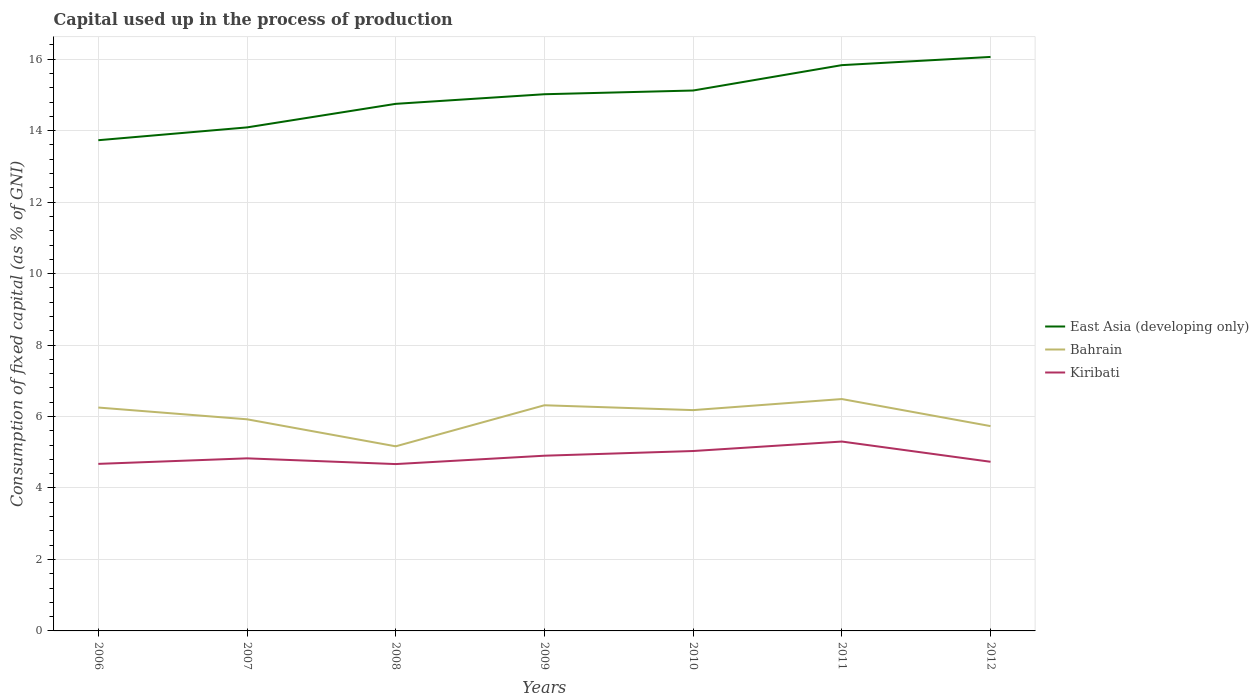How many different coloured lines are there?
Make the answer very short. 3. Is the number of lines equal to the number of legend labels?
Offer a very short reply. Yes. Across all years, what is the maximum capital used up in the process of production in Kiribati?
Keep it short and to the point. 4.67. In which year was the capital used up in the process of production in Bahrain maximum?
Provide a short and direct response. 2008. What is the total capital used up in the process of production in Bahrain in the graph?
Provide a succinct answer. -1.32. What is the difference between the highest and the second highest capital used up in the process of production in East Asia (developing only)?
Your answer should be compact. 2.33. How many years are there in the graph?
Ensure brevity in your answer.  7. What is the difference between two consecutive major ticks on the Y-axis?
Your answer should be very brief. 2. Does the graph contain any zero values?
Offer a terse response. No. Does the graph contain grids?
Make the answer very short. Yes. How many legend labels are there?
Your answer should be very brief. 3. How are the legend labels stacked?
Provide a short and direct response. Vertical. What is the title of the graph?
Ensure brevity in your answer.  Capital used up in the process of production. Does "Jordan" appear as one of the legend labels in the graph?
Keep it short and to the point. No. What is the label or title of the Y-axis?
Provide a short and direct response. Consumption of fixed capital (as % of GNI). What is the Consumption of fixed capital (as % of GNI) in East Asia (developing only) in 2006?
Offer a very short reply. 13.73. What is the Consumption of fixed capital (as % of GNI) in Bahrain in 2006?
Keep it short and to the point. 6.25. What is the Consumption of fixed capital (as % of GNI) in Kiribati in 2006?
Your answer should be very brief. 4.68. What is the Consumption of fixed capital (as % of GNI) in East Asia (developing only) in 2007?
Your answer should be very brief. 14.09. What is the Consumption of fixed capital (as % of GNI) in Bahrain in 2007?
Your answer should be compact. 5.92. What is the Consumption of fixed capital (as % of GNI) of Kiribati in 2007?
Provide a succinct answer. 4.83. What is the Consumption of fixed capital (as % of GNI) of East Asia (developing only) in 2008?
Ensure brevity in your answer.  14.75. What is the Consumption of fixed capital (as % of GNI) of Bahrain in 2008?
Offer a terse response. 5.17. What is the Consumption of fixed capital (as % of GNI) of Kiribati in 2008?
Offer a terse response. 4.67. What is the Consumption of fixed capital (as % of GNI) in East Asia (developing only) in 2009?
Provide a short and direct response. 15.02. What is the Consumption of fixed capital (as % of GNI) of Bahrain in 2009?
Ensure brevity in your answer.  6.32. What is the Consumption of fixed capital (as % of GNI) of Kiribati in 2009?
Provide a short and direct response. 4.9. What is the Consumption of fixed capital (as % of GNI) in East Asia (developing only) in 2010?
Make the answer very short. 15.12. What is the Consumption of fixed capital (as % of GNI) of Bahrain in 2010?
Give a very brief answer. 6.18. What is the Consumption of fixed capital (as % of GNI) of Kiribati in 2010?
Keep it short and to the point. 5.03. What is the Consumption of fixed capital (as % of GNI) in East Asia (developing only) in 2011?
Your response must be concise. 15.83. What is the Consumption of fixed capital (as % of GNI) of Bahrain in 2011?
Offer a terse response. 6.49. What is the Consumption of fixed capital (as % of GNI) of Kiribati in 2011?
Keep it short and to the point. 5.3. What is the Consumption of fixed capital (as % of GNI) of East Asia (developing only) in 2012?
Your answer should be very brief. 16.06. What is the Consumption of fixed capital (as % of GNI) in Bahrain in 2012?
Keep it short and to the point. 5.73. What is the Consumption of fixed capital (as % of GNI) in Kiribati in 2012?
Offer a very short reply. 4.73. Across all years, what is the maximum Consumption of fixed capital (as % of GNI) in East Asia (developing only)?
Your answer should be very brief. 16.06. Across all years, what is the maximum Consumption of fixed capital (as % of GNI) in Bahrain?
Your answer should be very brief. 6.49. Across all years, what is the maximum Consumption of fixed capital (as % of GNI) in Kiribati?
Offer a very short reply. 5.3. Across all years, what is the minimum Consumption of fixed capital (as % of GNI) in East Asia (developing only)?
Your answer should be compact. 13.73. Across all years, what is the minimum Consumption of fixed capital (as % of GNI) in Bahrain?
Your answer should be compact. 5.17. Across all years, what is the minimum Consumption of fixed capital (as % of GNI) in Kiribati?
Your answer should be compact. 4.67. What is the total Consumption of fixed capital (as % of GNI) in East Asia (developing only) in the graph?
Your response must be concise. 104.61. What is the total Consumption of fixed capital (as % of GNI) in Bahrain in the graph?
Make the answer very short. 42.06. What is the total Consumption of fixed capital (as % of GNI) in Kiribati in the graph?
Offer a very short reply. 34.15. What is the difference between the Consumption of fixed capital (as % of GNI) of East Asia (developing only) in 2006 and that in 2007?
Provide a succinct answer. -0.36. What is the difference between the Consumption of fixed capital (as % of GNI) of Bahrain in 2006 and that in 2007?
Your response must be concise. 0.33. What is the difference between the Consumption of fixed capital (as % of GNI) of Kiribati in 2006 and that in 2007?
Offer a very short reply. -0.15. What is the difference between the Consumption of fixed capital (as % of GNI) of East Asia (developing only) in 2006 and that in 2008?
Your answer should be very brief. -1.02. What is the difference between the Consumption of fixed capital (as % of GNI) of Bahrain in 2006 and that in 2008?
Ensure brevity in your answer.  1.09. What is the difference between the Consumption of fixed capital (as % of GNI) of Kiribati in 2006 and that in 2008?
Offer a very short reply. 0.01. What is the difference between the Consumption of fixed capital (as % of GNI) of East Asia (developing only) in 2006 and that in 2009?
Keep it short and to the point. -1.29. What is the difference between the Consumption of fixed capital (as % of GNI) in Bahrain in 2006 and that in 2009?
Make the answer very short. -0.06. What is the difference between the Consumption of fixed capital (as % of GNI) of Kiribati in 2006 and that in 2009?
Keep it short and to the point. -0.23. What is the difference between the Consumption of fixed capital (as % of GNI) in East Asia (developing only) in 2006 and that in 2010?
Make the answer very short. -1.39. What is the difference between the Consumption of fixed capital (as % of GNI) of Bahrain in 2006 and that in 2010?
Give a very brief answer. 0.07. What is the difference between the Consumption of fixed capital (as % of GNI) of Kiribati in 2006 and that in 2010?
Give a very brief answer. -0.36. What is the difference between the Consumption of fixed capital (as % of GNI) in East Asia (developing only) in 2006 and that in 2011?
Provide a succinct answer. -2.1. What is the difference between the Consumption of fixed capital (as % of GNI) of Bahrain in 2006 and that in 2011?
Offer a terse response. -0.24. What is the difference between the Consumption of fixed capital (as % of GNI) of Kiribati in 2006 and that in 2011?
Make the answer very short. -0.62. What is the difference between the Consumption of fixed capital (as % of GNI) of East Asia (developing only) in 2006 and that in 2012?
Keep it short and to the point. -2.33. What is the difference between the Consumption of fixed capital (as % of GNI) of Bahrain in 2006 and that in 2012?
Offer a very short reply. 0.52. What is the difference between the Consumption of fixed capital (as % of GNI) of Kiribati in 2006 and that in 2012?
Provide a succinct answer. -0.06. What is the difference between the Consumption of fixed capital (as % of GNI) of East Asia (developing only) in 2007 and that in 2008?
Offer a very short reply. -0.66. What is the difference between the Consumption of fixed capital (as % of GNI) in Bahrain in 2007 and that in 2008?
Your answer should be very brief. 0.76. What is the difference between the Consumption of fixed capital (as % of GNI) of Kiribati in 2007 and that in 2008?
Give a very brief answer. 0.16. What is the difference between the Consumption of fixed capital (as % of GNI) in East Asia (developing only) in 2007 and that in 2009?
Give a very brief answer. -0.93. What is the difference between the Consumption of fixed capital (as % of GNI) in Bahrain in 2007 and that in 2009?
Provide a short and direct response. -0.39. What is the difference between the Consumption of fixed capital (as % of GNI) in Kiribati in 2007 and that in 2009?
Ensure brevity in your answer.  -0.07. What is the difference between the Consumption of fixed capital (as % of GNI) in East Asia (developing only) in 2007 and that in 2010?
Provide a succinct answer. -1.03. What is the difference between the Consumption of fixed capital (as % of GNI) of Bahrain in 2007 and that in 2010?
Provide a short and direct response. -0.26. What is the difference between the Consumption of fixed capital (as % of GNI) of Kiribati in 2007 and that in 2010?
Offer a very short reply. -0.21. What is the difference between the Consumption of fixed capital (as % of GNI) in East Asia (developing only) in 2007 and that in 2011?
Your answer should be compact. -1.74. What is the difference between the Consumption of fixed capital (as % of GNI) in Bahrain in 2007 and that in 2011?
Offer a very short reply. -0.57. What is the difference between the Consumption of fixed capital (as % of GNI) in Kiribati in 2007 and that in 2011?
Offer a terse response. -0.47. What is the difference between the Consumption of fixed capital (as % of GNI) of East Asia (developing only) in 2007 and that in 2012?
Offer a terse response. -1.97. What is the difference between the Consumption of fixed capital (as % of GNI) of Bahrain in 2007 and that in 2012?
Give a very brief answer. 0.19. What is the difference between the Consumption of fixed capital (as % of GNI) in Kiribati in 2007 and that in 2012?
Ensure brevity in your answer.  0.1. What is the difference between the Consumption of fixed capital (as % of GNI) of East Asia (developing only) in 2008 and that in 2009?
Your response must be concise. -0.27. What is the difference between the Consumption of fixed capital (as % of GNI) in Bahrain in 2008 and that in 2009?
Your answer should be compact. -1.15. What is the difference between the Consumption of fixed capital (as % of GNI) of Kiribati in 2008 and that in 2009?
Offer a very short reply. -0.23. What is the difference between the Consumption of fixed capital (as % of GNI) of East Asia (developing only) in 2008 and that in 2010?
Make the answer very short. -0.37. What is the difference between the Consumption of fixed capital (as % of GNI) of Bahrain in 2008 and that in 2010?
Offer a very short reply. -1.01. What is the difference between the Consumption of fixed capital (as % of GNI) of Kiribati in 2008 and that in 2010?
Make the answer very short. -0.37. What is the difference between the Consumption of fixed capital (as % of GNI) of East Asia (developing only) in 2008 and that in 2011?
Give a very brief answer. -1.08. What is the difference between the Consumption of fixed capital (as % of GNI) in Bahrain in 2008 and that in 2011?
Ensure brevity in your answer.  -1.32. What is the difference between the Consumption of fixed capital (as % of GNI) of Kiribati in 2008 and that in 2011?
Ensure brevity in your answer.  -0.63. What is the difference between the Consumption of fixed capital (as % of GNI) of East Asia (developing only) in 2008 and that in 2012?
Provide a succinct answer. -1.31. What is the difference between the Consumption of fixed capital (as % of GNI) in Bahrain in 2008 and that in 2012?
Provide a short and direct response. -0.57. What is the difference between the Consumption of fixed capital (as % of GNI) of Kiribati in 2008 and that in 2012?
Offer a very short reply. -0.06. What is the difference between the Consumption of fixed capital (as % of GNI) in East Asia (developing only) in 2009 and that in 2010?
Your response must be concise. -0.1. What is the difference between the Consumption of fixed capital (as % of GNI) in Bahrain in 2009 and that in 2010?
Keep it short and to the point. 0.14. What is the difference between the Consumption of fixed capital (as % of GNI) in Kiribati in 2009 and that in 2010?
Your answer should be compact. -0.13. What is the difference between the Consumption of fixed capital (as % of GNI) in East Asia (developing only) in 2009 and that in 2011?
Make the answer very short. -0.81. What is the difference between the Consumption of fixed capital (as % of GNI) of Bahrain in 2009 and that in 2011?
Your answer should be very brief. -0.17. What is the difference between the Consumption of fixed capital (as % of GNI) of Kiribati in 2009 and that in 2011?
Your answer should be very brief. -0.4. What is the difference between the Consumption of fixed capital (as % of GNI) in East Asia (developing only) in 2009 and that in 2012?
Provide a succinct answer. -1.04. What is the difference between the Consumption of fixed capital (as % of GNI) in Bahrain in 2009 and that in 2012?
Keep it short and to the point. 0.58. What is the difference between the Consumption of fixed capital (as % of GNI) of Kiribati in 2009 and that in 2012?
Provide a succinct answer. 0.17. What is the difference between the Consumption of fixed capital (as % of GNI) of East Asia (developing only) in 2010 and that in 2011?
Offer a terse response. -0.71. What is the difference between the Consumption of fixed capital (as % of GNI) of Bahrain in 2010 and that in 2011?
Offer a terse response. -0.31. What is the difference between the Consumption of fixed capital (as % of GNI) in Kiribati in 2010 and that in 2011?
Your answer should be very brief. -0.27. What is the difference between the Consumption of fixed capital (as % of GNI) of East Asia (developing only) in 2010 and that in 2012?
Make the answer very short. -0.94. What is the difference between the Consumption of fixed capital (as % of GNI) of Bahrain in 2010 and that in 2012?
Give a very brief answer. 0.45. What is the difference between the Consumption of fixed capital (as % of GNI) in Kiribati in 2010 and that in 2012?
Provide a short and direct response. 0.3. What is the difference between the Consumption of fixed capital (as % of GNI) of East Asia (developing only) in 2011 and that in 2012?
Your answer should be compact. -0.23. What is the difference between the Consumption of fixed capital (as % of GNI) in Bahrain in 2011 and that in 2012?
Provide a succinct answer. 0.76. What is the difference between the Consumption of fixed capital (as % of GNI) in Kiribati in 2011 and that in 2012?
Provide a succinct answer. 0.57. What is the difference between the Consumption of fixed capital (as % of GNI) in East Asia (developing only) in 2006 and the Consumption of fixed capital (as % of GNI) in Bahrain in 2007?
Keep it short and to the point. 7.81. What is the difference between the Consumption of fixed capital (as % of GNI) in East Asia (developing only) in 2006 and the Consumption of fixed capital (as % of GNI) in Kiribati in 2007?
Ensure brevity in your answer.  8.9. What is the difference between the Consumption of fixed capital (as % of GNI) of Bahrain in 2006 and the Consumption of fixed capital (as % of GNI) of Kiribati in 2007?
Offer a terse response. 1.42. What is the difference between the Consumption of fixed capital (as % of GNI) in East Asia (developing only) in 2006 and the Consumption of fixed capital (as % of GNI) in Bahrain in 2008?
Provide a succinct answer. 8.57. What is the difference between the Consumption of fixed capital (as % of GNI) of East Asia (developing only) in 2006 and the Consumption of fixed capital (as % of GNI) of Kiribati in 2008?
Provide a succinct answer. 9.06. What is the difference between the Consumption of fixed capital (as % of GNI) of Bahrain in 2006 and the Consumption of fixed capital (as % of GNI) of Kiribati in 2008?
Your response must be concise. 1.58. What is the difference between the Consumption of fixed capital (as % of GNI) of East Asia (developing only) in 2006 and the Consumption of fixed capital (as % of GNI) of Bahrain in 2009?
Keep it short and to the point. 7.42. What is the difference between the Consumption of fixed capital (as % of GNI) of East Asia (developing only) in 2006 and the Consumption of fixed capital (as % of GNI) of Kiribati in 2009?
Provide a short and direct response. 8.83. What is the difference between the Consumption of fixed capital (as % of GNI) of Bahrain in 2006 and the Consumption of fixed capital (as % of GNI) of Kiribati in 2009?
Provide a short and direct response. 1.35. What is the difference between the Consumption of fixed capital (as % of GNI) in East Asia (developing only) in 2006 and the Consumption of fixed capital (as % of GNI) in Bahrain in 2010?
Offer a very short reply. 7.55. What is the difference between the Consumption of fixed capital (as % of GNI) of East Asia (developing only) in 2006 and the Consumption of fixed capital (as % of GNI) of Kiribati in 2010?
Provide a short and direct response. 8.7. What is the difference between the Consumption of fixed capital (as % of GNI) in Bahrain in 2006 and the Consumption of fixed capital (as % of GNI) in Kiribati in 2010?
Give a very brief answer. 1.22. What is the difference between the Consumption of fixed capital (as % of GNI) in East Asia (developing only) in 2006 and the Consumption of fixed capital (as % of GNI) in Bahrain in 2011?
Offer a very short reply. 7.24. What is the difference between the Consumption of fixed capital (as % of GNI) of East Asia (developing only) in 2006 and the Consumption of fixed capital (as % of GNI) of Kiribati in 2011?
Ensure brevity in your answer.  8.43. What is the difference between the Consumption of fixed capital (as % of GNI) of Bahrain in 2006 and the Consumption of fixed capital (as % of GNI) of Kiribati in 2011?
Provide a short and direct response. 0.95. What is the difference between the Consumption of fixed capital (as % of GNI) of East Asia (developing only) in 2006 and the Consumption of fixed capital (as % of GNI) of Bahrain in 2012?
Your answer should be compact. 8. What is the difference between the Consumption of fixed capital (as % of GNI) in East Asia (developing only) in 2006 and the Consumption of fixed capital (as % of GNI) in Kiribati in 2012?
Provide a succinct answer. 9. What is the difference between the Consumption of fixed capital (as % of GNI) in Bahrain in 2006 and the Consumption of fixed capital (as % of GNI) in Kiribati in 2012?
Provide a short and direct response. 1.52. What is the difference between the Consumption of fixed capital (as % of GNI) in East Asia (developing only) in 2007 and the Consumption of fixed capital (as % of GNI) in Bahrain in 2008?
Offer a very short reply. 8.93. What is the difference between the Consumption of fixed capital (as % of GNI) of East Asia (developing only) in 2007 and the Consumption of fixed capital (as % of GNI) of Kiribati in 2008?
Make the answer very short. 9.42. What is the difference between the Consumption of fixed capital (as % of GNI) of Bahrain in 2007 and the Consumption of fixed capital (as % of GNI) of Kiribati in 2008?
Your response must be concise. 1.25. What is the difference between the Consumption of fixed capital (as % of GNI) of East Asia (developing only) in 2007 and the Consumption of fixed capital (as % of GNI) of Bahrain in 2009?
Your answer should be compact. 7.78. What is the difference between the Consumption of fixed capital (as % of GNI) in East Asia (developing only) in 2007 and the Consumption of fixed capital (as % of GNI) in Kiribati in 2009?
Your answer should be compact. 9.19. What is the difference between the Consumption of fixed capital (as % of GNI) of Bahrain in 2007 and the Consumption of fixed capital (as % of GNI) of Kiribati in 2009?
Keep it short and to the point. 1.02. What is the difference between the Consumption of fixed capital (as % of GNI) of East Asia (developing only) in 2007 and the Consumption of fixed capital (as % of GNI) of Bahrain in 2010?
Offer a terse response. 7.91. What is the difference between the Consumption of fixed capital (as % of GNI) in East Asia (developing only) in 2007 and the Consumption of fixed capital (as % of GNI) in Kiribati in 2010?
Make the answer very short. 9.06. What is the difference between the Consumption of fixed capital (as % of GNI) of Bahrain in 2007 and the Consumption of fixed capital (as % of GNI) of Kiribati in 2010?
Your response must be concise. 0.89. What is the difference between the Consumption of fixed capital (as % of GNI) of East Asia (developing only) in 2007 and the Consumption of fixed capital (as % of GNI) of Bahrain in 2011?
Offer a very short reply. 7.6. What is the difference between the Consumption of fixed capital (as % of GNI) of East Asia (developing only) in 2007 and the Consumption of fixed capital (as % of GNI) of Kiribati in 2011?
Provide a short and direct response. 8.79. What is the difference between the Consumption of fixed capital (as % of GNI) in Bahrain in 2007 and the Consumption of fixed capital (as % of GNI) in Kiribati in 2011?
Offer a very short reply. 0.62. What is the difference between the Consumption of fixed capital (as % of GNI) of East Asia (developing only) in 2007 and the Consumption of fixed capital (as % of GNI) of Bahrain in 2012?
Offer a terse response. 8.36. What is the difference between the Consumption of fixed capital (as % of GNI) of East Asia (developing only) in 2007 and the Consumption of fixed capital (as % of GNI) of Kiribati in 2012?
Your response must be concise. 9.36. What is the difference between the Consumption of fixed capital (as % of GNI) of Bahrain in 2007 and the Consumption of fixed capital (as % of GNI) of Kiribati in 2012?
Offer a very short reply. 1.19. What is the difference between the Consumption of fixed capital (as % of GNI) of East Asia (developing only) in 2008 and the Consumption of fixed capital (as % of GNI) of Bahrain in 2009?
Provide a short and direct response. 8.44. What is the difference between the Consumption of fixed capital (as % of GNI) in East Asia (developing only) in 2008 and the Consumption of fixed capital (as % of GNI) in Kiribati in 2009?
Provide a succinct answer. 9.85. What is the difference between the Consumption of fixed capital (as % of GNI) in Bahrain in 2008 and the Consumption of fixed capital (as % of GNI) in Kiribati in 2009?
Give a very brief answer. 0.26. What is the difference between the Consumption of fixed capital (as % of GNI) of East Asia (developing only) in 2008 and the Consumption of fixed capital (as % of GNI) of Bahrain in 2010?
Your answer should be very brief. 8.57. What is the difference between the Consumption of fixed capital (as % of GNI) of East Asia (developing only) in 2008 and the Consumption of fixed capital (as % of GNI) of Kiribati in 2010?
Your answer should be compact. 9.72. What is the difference between the Consumption of fixed capital (as % of GNI) of Bahrain in 2008 and the Consumption of fixed capital (as % of GNI) of Kiribati in 2010?
Offer a terse response. 0.13. What is the difference between the Consumption of fixed capital (as % of GNI) of East Asia (developing only) in 2008 and the Consumption of fixed capital (as % of GNI) of Bahrain in 2011?
Provide a succinct answer. 8.26. What is the difference between the Consumption of fixed capital (as % of GNI) of East Asia (developing only) in 2008 and the Consumption of fixed capital (as % of GNI) of Kiribati in 2011?
Your response must be concise. 9.45. What is the difference between the Consumption of fixed capital (as % of GNI) of Bahrain in 2008 and the Consumption of fixed capital (as % of GNI) of Kiribati in 2011?
Give a very brief answer. -0.13. What is the difference between the Consumption of fixed capital (as % of GNI) in East Asia (developing only) in 2008 and the Consumption of fixed capital (as % of GNI) in Bahrain in 2012?
Provide a succinct answer. 9.02. What is the difference between the Consumption of fixed capital (as % of GNI) in East Asia (developing only) in 2008 and the Consumption of fixed capital (as % of GNI) in Kiribati in 2012?
Your answer should be very brief. 10.02. What is the difference between the Consumption of fixed capital (as % of GNI) in Bahrain in 2008 and the Consumption of fixed capital (as % of GNI) in Kiribati in 2012?
Give a very brief answer. 0.43. What is the difference between the Consumption of fixed capital (as % of GNI) in East Asia (developing only) in 2009 and the Consumption of fixed capital (as % of GNI) in Bahrain in 2010?
Provide a succinct answer. 8.84. What is the difference between the Consumption of fixed capital (as % of GNI) of East Asia (developing only) in 2009 and the Consumption of fixed capital (as % of GNI) of Kiribati in 2010?
Offer a terse response. 9.98. What is the difference between the Consumption of fixed capital (as % of GNI) of Bahrain in 2009 and the Consumption of fixed capital (as % of GNI) of Kiribati in 2010?
Offer a terse response. 1.28. What is the difference between the Consumption of fixed capital (as % of GNI) in East Asia (developing only) in 2009 and the Consumption of fixed capital (as % of GNI) in Bahrain in 2011?
Offer a terse response. 8.53. What is the difference between the Consumption of fixed capital (as % of GNI) of East Asia (developing only) in 2009 and the Consumption of fixed capital (as % of GNI) of Kiribati in 2011?
Make the answer very short. 9.72. What is the difference between the Consumption of fixed capital (as % of GNI) of Bahrain in 2009 and the Consumption of fixed capital (as % of GNI) of Kiribati in 2011?
Make the answer very short. 1.02. What is the difference between the Consumption of fixed capital (as % of GNI) of East Asia (developing only) in 2009 and the Consumption of fixed capital (as % of GNI) of Bahrain in 2012?
Provide a succinct answer. 9.29. What is the difference between the Consumption of fixed capital (as % of GNI) in East Asia (developing only) in 2009 and the Consumption of fixed capital (as % of GNI) in Kiribati in 2012?
Provide a succinct answer. 10.29. What is the difference between the Consumption of fixed capital (as % of GNI) in Bahrain in 2009 and the Consumption of fixed capital (as % of GNI) in Kiribati in 2012?
Keep it short and to the point. 1.58. What is the difference between the Consumption of fixed capital (as % of GNI) of East Asia (developing only) in 2010 and the Consumption of fixed capital (as % of GNI) of Bahrain in 2011?
Provide a short and direct response. 8.63. What is the difference between the Consumption of fixed capital (as % of GNI) in East Asia (developing only) in 2010 and the Consumption of fixed capital (as % of GNI) in Kiribati in 2011?
Offer a terse response. 9.82. What is the difference between the Consumption of fixed capital (as % of GNI) of Bahrain in 2010 and the Consumption of fixed capital (as % of GNI) of Kiribati in 2011?
Give a very brief answer. 0.88. What is the difference between the Consumption of fixed capital (as % of GNI) in East Asia (developing only) in 2010 and the Consumption of fixed capital (as % of GNI) in Bahrain in 2012?
Your response must be concise. 9.39. What is the difference between the Consumption of fixed capital (as % of GNI) in East Asia (developing only) in 2010 and the Consumption of fixed capital (as % of GNI) in Kiribati in 2012?
Your answer should be very brief. 10.39. What is the difference between the Consumption of fixed capital (as % of GNI) in Bahrain in 2010 and the Consumption of fixed capital (as % of GNI) in Kiribati in 2012?
Keep it short and to the point. 1.45. What is the difference between the Consumption of fixed capital (as % of GNI) in East Asia (developing only) in 2011 and the Consumption of fixed capital (as % of GNI) in Bahrain in 2012?
Your response must be concise. 10.1. What is the difference between the Consumption of fixed capital (as % of GNI) in East Asia (developing only) in 2011 and the Consumption of fixed capital (as % of GNI) in Kiribati in 2012?
Ensure brevity in your answer.  11.1. What is the difference between the Consumption of fixed capital (as % of GNI) of Bahrain in 2011 and the Consumption of fixed capital (as % of GNI) of Kiribati in 2012?
Offer a terse response. 1.76. What is the average Consumption of fixed capital (as % of GNI) of East Asia (developing only) per year?
Provide a succinct answer. 14.94. What is the average Consumption of fixed capital (as % of GNI) of Bahrain per year?
Give a very brief answer. 6.01. What is the average Consumption of fixed capital (as % of GNI) of Kiribati per year?
Make the answer very short. 4.88. In the year 2006, what is the difference between the Consumption of fixed capital (as % of GNI) in East Asia (developing only) and Consumption of fixed capital (as % of GNI) in Bahrain?
Ensure brevity in your answer.  7.48. In the year 2006, what is the difference between the Consumption of fixed capital (as % of GNI) of East Asia (developing only) and Consumption of fixed capital (as % of GNI) of Kiribati?
Your answer should be very brief. 9.06. In the year 2006, what is the difference between the Consumption of fixed capital (as % of GNI) of Bahrain and Consumption of fixed capital (as % of GNI) of Kiribati?
Ensure brevity in your answer.  1.58. In the year 2007, what is the difference between the Consumption of fixed capital (as % of GNI) of East Asia (developing only) and Consumption of fixed capital (as % of GNI) of Bahrain?
Provide a short and direct response. 8.17. In the year 2007, what is the difference between the Consumption of fixed capital (as % of GNI) in East Asia (developing only) and Consumption of fixed capital (as % of GNI) in Kiribati?
Offer a terse response. 9.26. In the year 2007, what is the difference between the Consumption of fixed capital (as % of GNI) of Bahrain and Consumption of fixed capital (as % of GNI) of Kiribati?
Provide a short and direct response. 1.09. In the year 2008, what is the difference between the Consumption of fixed capital (as % of GNI) of East Asia (developing only) and Consumption of fixed capital (as % of GNI) of Bahrain?
Give a very brief answer. 9.58. In the year 2008, what is the difference between the Consumption of fixed capital (as % of GNI) of East Asia (developing only) and Consumption of fixed capital (as % of GNI) of Kiribati?
Keep it short and to the point. 10.08. In the year 2008, what is the difference between the Consumption of fixed capital (as % of GNI) in Bahrain and Consumption of fixed capital (as % of GNI) in Kiribati?
Offer a terse response. 0.5. In the year 2009, what is the difference between the Consumption of fixed capital (as % of GNI) of East Asia (developing only) and Consumption of fixed capital (as % of GNI) of Bahrain?
Your answer should be very brief. 8.7. In the year 2009, what is the difference between the Consumption of fixed capital (as % of GNI) in East Asia (developing only) and Consumption of fixed capital (as % of GNI) in Kiribati?
Provide a short and direct response. 10.12. In the year 2009, what is the difference between the Consumption of fixed capital (as % of GNI) in Bahrain and Consumption of fixed capital (as % of GNI) in Kiribati?
Provide a short and direct response. 1.41. In the year 2010, what is the difference between the Consumption of fixed capital (as % of GNI) of East Asia (developing only) and Consumption of fixed capital (as % of GNI) of Bahrain?
Keep it short and to the point. 8.94. In the year 2010, what is the difference between the Consumption of fixed capital (as % of GNI) of East Asia (developing only) and Consumption of fixed capital (as % of GNI) of Kiribati?
Your response must be concise. 10.09. In the year 2010, what is the difference between the Consumption of fixed capital (as % of GNI) in Bahrain and Consumption of fixed capital (as % of GNI) in Kiribati?
Provide a succinct answer. 1.14. In the year 2011, what is the difference between the Consumption of fixed capital (as % of GNI) in East Asia (developing only) and Consumption of fixed capital (as % of GNI) in Bahrain?
Keep it short and to the point. 9.34. In the year 2011, what is the difference between the Consumption of fixed capital (as % of GNI) in East Asia (developing only) and Consumption of fixed capital (as % of GNI) in Kiribati?
Provide a short and direct response. 10.53. In the year 2011, what is the difference between the Consumption of fixed capital (as % of GNI) of Bahrain and Consumption of fixed capital (as % of GNI) of Kiribati?
Your answer should be compact. 1.19. In the year 2012, what is the difference between the Consumption of fixed capital (as % of GNI) in East Asia (developing only) and Consumption of fixed capital (as % of GNI) in Bahrain?
Your answer should be very brief. 10.33. In the year 2012, what is the difference between the Consumption of fixed capital (as % of GNI) in East Asia (developing only) and Consumption of fixed capital (as % of GNI) in Kiribati?
Keep it short and to the point. 11.33. What is the ratio of the Consumption of fixed capital (as % of GNI) of East Asia (developing only) in 2006 to that in 2007?
Give a very brief answer. 0.97. What is the ratio of the Consumption of fixed capital (as % of GNI) of Bahrain in 2006 to that in 2007?
Make the answer very short. 1.06. What is the ratio of the Consumption of fixed capital (as % of GNI) in Kiribati in 2006 to that in 2007?
Make the answer very short. 0.97. What is the ratio of the Consumption of fixed capital (as % of GNI) in Bahrain in 2006 to that in 2008?
Give a very brief answer. 1.21. What is the ratio of the Consumption of fixed capital (as % of GNI) in East Asia (developing only) in 2006 to that in 2009?
Your answer should be compact. 0.91. What is the ratio of the Consumption of fixed capital (as % of GNI) of Kiribati in 2006 to that in 2009?
Provide a short and direct response. 0.95. What is the ratio of the Consumption of fixed capital (as % of GNI) of East Asia (developing only) in 2006 to that in 2010?
Provide a succinct answer. 0.91. What is the ratio of the Consumption of fixed capital (as % of GNI) of Bahrain in 2006 to that in 2010?
Give a very brief answer. 1.01. What is the ratio of the Consumption of fixed capital (as % of GNI) in East Asia (developing only) in 2006 to that in 2011?
Keep it short and to the point. 0.87. What is the ratio of the Consumption of fixed capital (as % of GNI) of Bahrain in 2006 to that in 2011?
Keep it short and to the point. 0.96. What is the ratio of the Consumption of fixed capital (as % of GNI) in Kiribati in 2006 to that in 2011?
Make the answer very short. 0.88. What is the ratio of the Consumption of fixed capital (as % of GNI) in East Asia (developing only) in 2006 to that in 2012?
Offer a very short reply. 0.85. What is the ratio of the Consumption of fixed capital (as % of GNI) of Bahrain in 2006 to that in 2012?
Your answer should be very brief. 1.09. What is the ratio of the Consumption of fixed capital (as % of GNI) in Kiribati in 2006 to that in 2012?
Provide a succinct answer. 0.99. What is the ratio of the Consumption of fixed capital (as % of GNI) of East Asia (developing only) in 2007 to that in 2008?
Keep it short and to the point. 0.96. What is the ratio of the Consumption of fixed capital (as % of GNI) of Bahrain in 2007 to that in 2008?
Make the answer very short. 1.15. What is the ratio of the Consumption of fixed capital (as % of GNI) in Kiribati in 2007 to that in 2008?
Ensure brevity in your answer.  1.03. What is the ratio of the Consumption of fixed capital (as % of GNI) in East Asia (developing only) in 2007 to that in 2009?
Keep it short and to the point. 0.94. What is the ratio of the Consumption of fixed capital (as % of GNI) in Bahrain in 2007 to that in 2009?
Provide a short and direct response. 0.94. What is the ratio of the Consumption of fixed capital (as % of GNI) of Kiribati in 2007 to that in 2009?
Keep it short and to the point. 0.98. What is the ratio of the Consumption of fixed capital (as % of GNI) of East Asia (developing only) in 2007 to that in 2010?
Offer a terse response. 0.93. What is the ratio of the Consumption of fixed capital (as % of GNI) of Bahrain in 2007 to that in 2010?
Your answer should be very brief. 0.96. What is the ratio of the Consumption of fixed capital (as % of GNI) of Kiribati in 2007 to that in 2010?
Offer a very short reply. 0.96. What is the ratio of the Consumption of fixed capital (as % of GNI) in East Asia (developing only) in 2007 to that in 2011?
Offer a terse response. 0.89. What is the ratio of the Consumption of fixed capital (as % of GNI) in Bahrain in 2007 to that in 2011?
Keep it short and to the point. 0.91. What is the ratio of the Consumption of fixed capital (as % of GNI) in Kiribati in 2007 to that in 2011?
Make the answer very short. 0.91. What is the ratio of the Consumption of fixed capital (as % of GNI) of East Asia (developing only) in 2007 to that in 2012?
Your answer should be compact. 0.88. What is the ratio of the Consumption of fixed capital (as % of GNI) of Bahrain in 2007 to that in 2012?
Make the answer very short. 1.03. What is the ratio of the Consumption of fixed capital (as % of GNI) in Kiribati in 2007 to that in 2012?
Keep it short and to the point. 1.02. What is the ratio of the Consumption of fixed capital (as % of GNI) in East Asia (developing only) in 2008 to that in 2009?
Provide a short and direct response. 0.98. What is the ratio of the Consumption of fixed capital (as % of GNI) of Bahrain in 2008 to that in 2009?
Ensure brevity in your answer.  0.82. What is the ratio of the Consumption of fixed capital (as % of GNI) in Kiribati in 2008 to that in 2009?
Make the answer very short. 0.95. What is the ratio of the Consumption of fixed capital (as % of GNI) in East Asia (developing only) in 2008 to that in 2010?
Your answer should be compact. 0.98. What is the ratio of the Consumption of fixed capital (as % of GNI) of Bahrain in 2008 to that in 2010?
Your response must be concise. 0.84. What is the ratio of the Consumption of fixed capital (as % of GNI) of Kiribati in 2008 to that in 2010?
Give a very brief answer. 0.93. What is the ratio of the Consumption of fixed capital (as % of GNI) in East Asia (developing only) in 2008 to that in 2011?
Give a very brief answer. 0.93. What is the ratio of the Consumption of fixed capital (as % of GNI) in Bahrain in 2008 to that in 2011?
Your response must be concise. 0.8. What is the ratio of the Consumption of fixed capital (as % of GNI) of Kiribati in 2008 to that in 2011?
Make the answer very short. 0.88. What is the ratio of the Consumption of fixed capital (as % of GNI) of East Asia (developing only) in 2008 to that in 2012?
Give a very brief answer. 0.92. What is the ratio of the Consumption of fixed capital (as % of GNI) of Bahrain in 2008 to that in 2012?
Give a very brief answer. 0.9. What is the ratio of the Consumption of fixed capital (as % of GNI) of Kiribati in 2008 to that in 2012?
Provide a succinct answer. 0.99. What is the ratio of the Consumption of fixed capital (as % of GNI) in East Asia (developing only) in 2009 to that in 2010?
Keep it short and to the point. 0.99. What is the ratio of the Consumption of fixed capital (as % of GNI) of East Asia (developing only) in 2009 to that in 2011?
Your answer should be compact. 0.95. What is the ratio of the Consumption of fixed capital (as % of GNI) of Bahrain in 2009 to that in 2011?
Keep it short and to the point. 0.97. What is the ratio of the Consumption of fixed capital (as % of GNI) in Kiribati in 2009 to that in 2011?
Your answer should be very brief. 0.93. What is the ratio of the Consumption of fixed capital (as % of GNI) of East Asia (developing only) in 2009 to that in 2012?
Keep it short and to the point. 0.94. What is the ratio of the Consumption of fixed capital (as % of GNI) of Bahrain in 2009 to that in 2012?
Your response must be concise. 1.1. What is the ratio of the Consumption of fixed capital (as % of GNI) in Kiribati in 2009 to that in 2012?
Your answer should be very brief. 1.04. What is the ratio of the Consumption of fixed capital (as % of GNI) of East Asia (developing only) in 2010 to that in 2011?
Offer a terse response. 0.96. What is the ratio of the Consumption of fixed capital (as % of GNI) in Bahrain in 2010 to that in 2011?
Your answer should be compact. 0.95. What is the ratio of the Consumption of fixed capital (as % of GNI) of East Asia (developing only) in 2010 to that in 2012?
Your response must be concise. 0.94. What is the ratio of the Consumption of fixed capital (as % of GNI) of Bahrain in 2010 to that in 2012?
Your response must be concise. 1.08. What is the ratio of the Consumption of fixed capital (as % of GNI) of Kiribati in 2010 to that in 2012?
Your response must be concise. 1.06. What is the ratio of the Consumption of fixed capital (as % of GNI) of East Asia (developing only) in 2011 to that in 2012?
Offer a terse response. 0.99. What is the ratio of the Consumption of fixed capital (as % of GNI) in Bahrain in 2011 to that in 2012?
Keep it short and to the point. 1.13. What is the ratio of the Consumption of fixed capital (as % of GNI) of Kiribati in 2011 to that in 2012?
Offer a terse response. 1.12. What is the difference between the highest and the second highest Consumption of fixed capital (as % of GNI) of East Asia (developing only)?
Keep it short and to the point. 0.23. What is the difference between the highest and the second highest Consumption of fixed capital (as % of GNI) of Bahrain?
Offer a terse response. 0.17. What is the difference between the highest and the second highest Consumption of fixed capital (as % of GNI) of Kiribati?
Your response must be concise. 0.27. What is the difference between the highest and the lowest Consumption of fixed capital (as % of GNI) of East Asia (developing only)?
Keep it short and to the point. 2.33. What is the difference between the highest and the lowest Consumption of fixed capital (as % of GNI) of Bahrain?
Your response must be concise. 1.32. What is the difference between the highest and the lowest Consumption of fixed capital (as % of GNI) of Kiribati?
Your response must be concise. 0.63. 